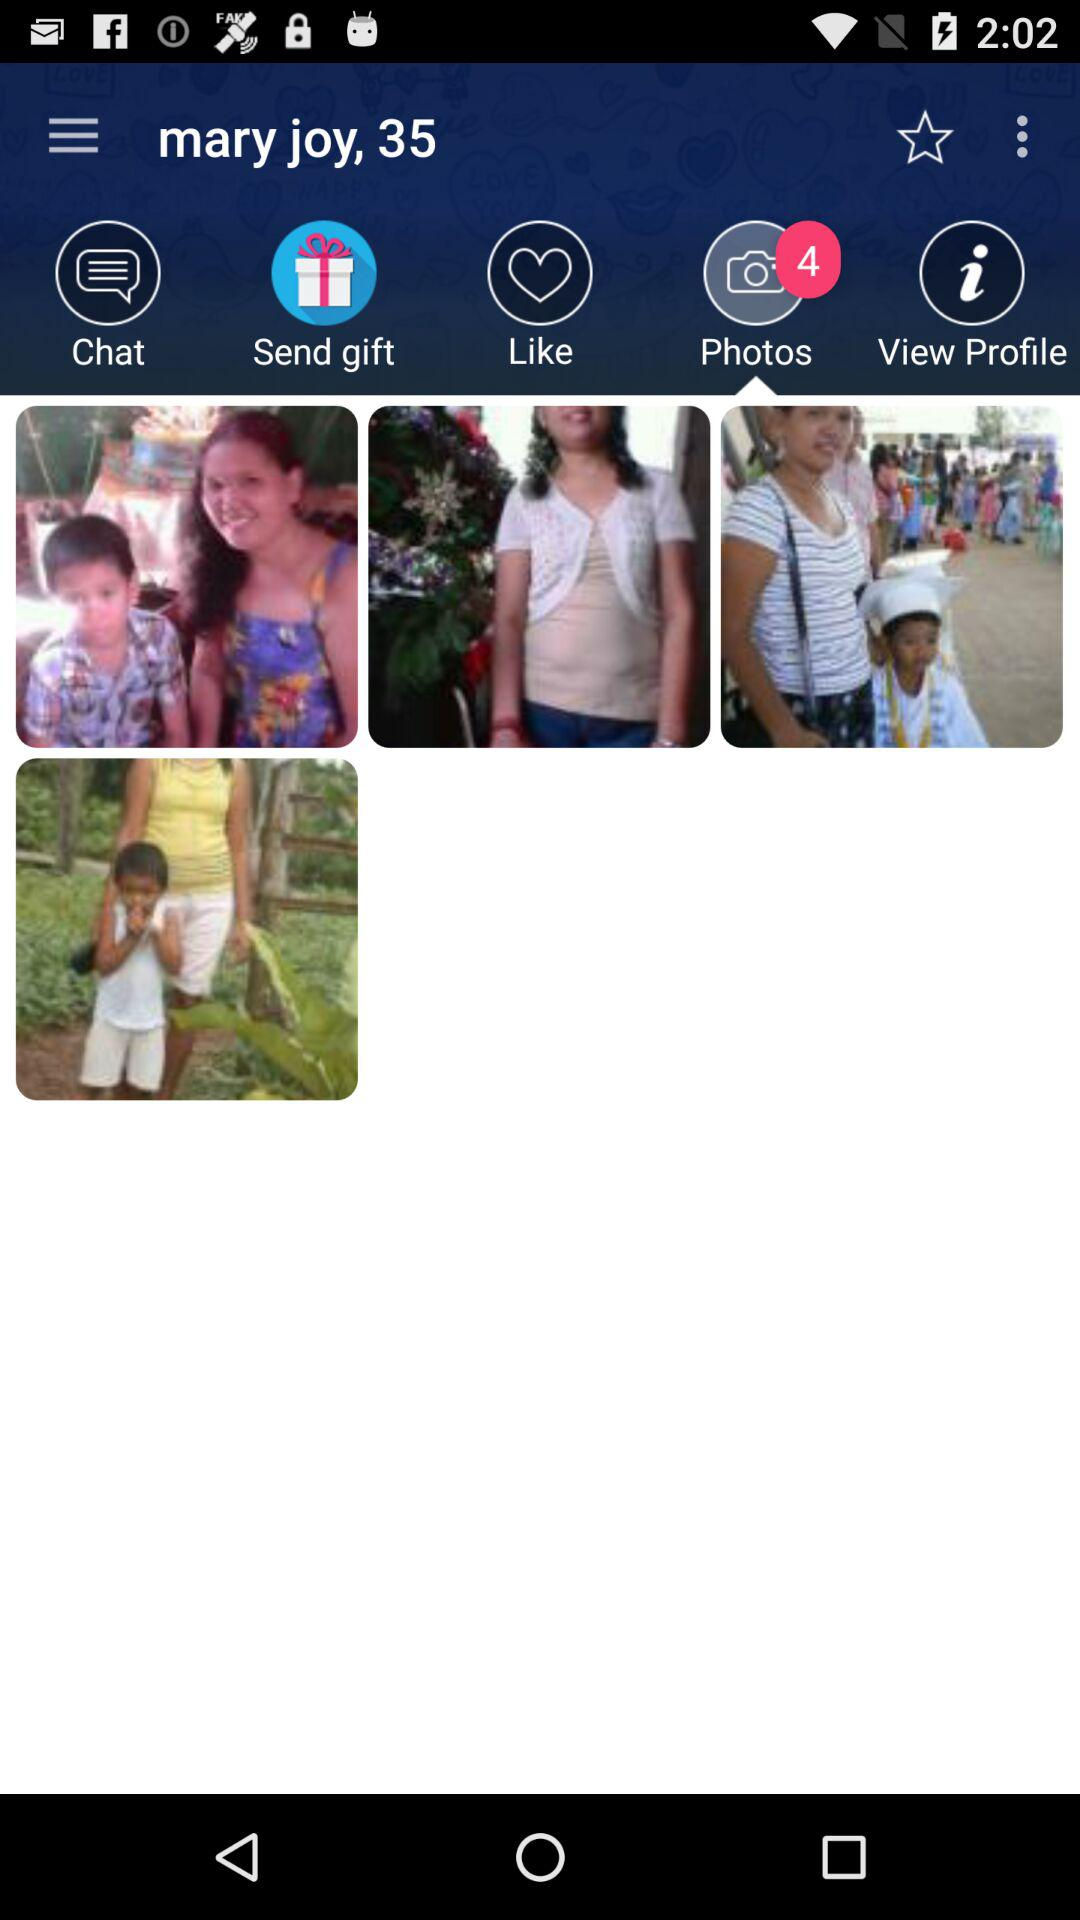What is the total number of photos? The total number of photos is 4. 